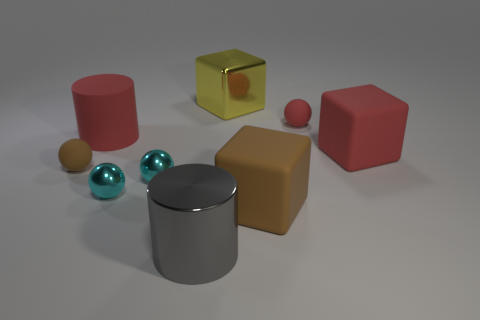What shape is the large metallic object that is in front of the brown object on the left side of the large metal cylinder?
Provide a short and direct response. Cylinder. What number of spheres are red rubber objects or big gray things?
Provide a succinct answer. 1. Does the big red matte object that is behind the red block have the same shape as the large metallic thing in front of the large yellow shiny cube?
Make the answer very short. Yes. There is a matte object that is in front of the big red matte cylinder and on the left side of the large gray cylinder; what color is it?
Keep it short and to the point. Brown. Does the rubber cylinder have the same color as the rubber cube on the right side of the red rubber sphere?
Your answer should be compact. Yes. What is the size of the rubber object that is both in front of the red rubber block and behind the large brown object?
Keep it short and to the point. Small. How many other objects are the same color as the rubber cylinder?
Your answer should be compact. 2. How big is the rubber sphere behind the cube to the right of the brown object that is to the right of the big gray thing?
Provide a succinct answer. Small. Are there any tiny objects behind the red cylinder?
Ensure brevity in your answer.  Yes. Does the metal cylinder have the same size as the brown thing that is to the left of the big rubber cylinder?
Provide a succinct answer. No. 